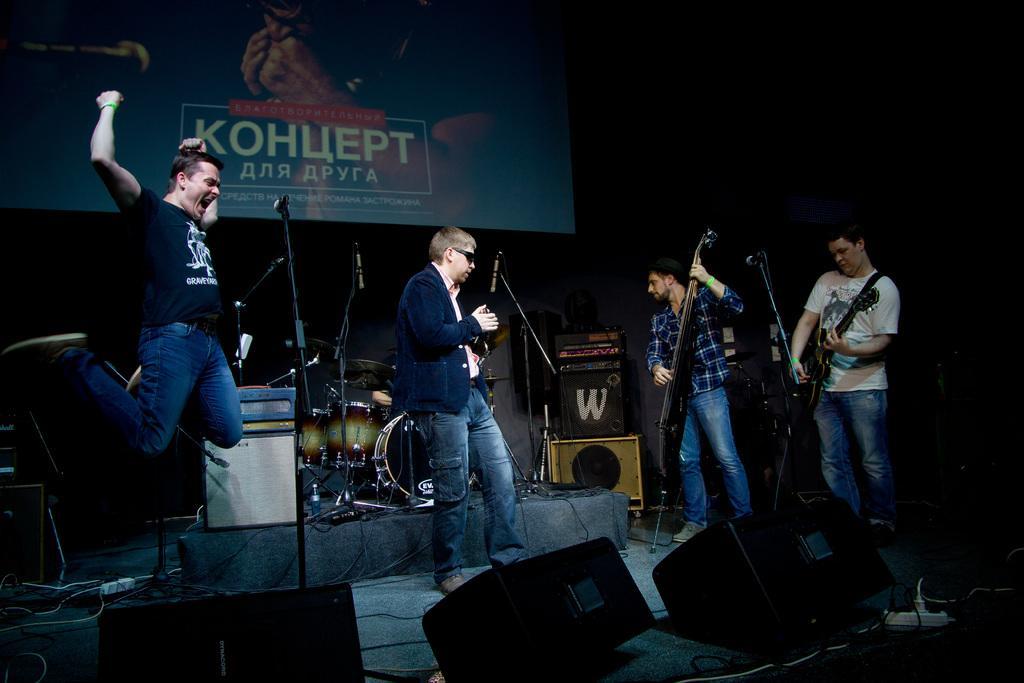In one or two sentences, can you explain what this image depicts? In this picture there is a man who are holding the guitars. On the left there is a man who is jumping. Behind them I can see the mic, stands, speech desk, drums and other musical instruments. At the bottom I can see the speakers. At the top I can see the banner. In the top right corner I can see the darkness. 